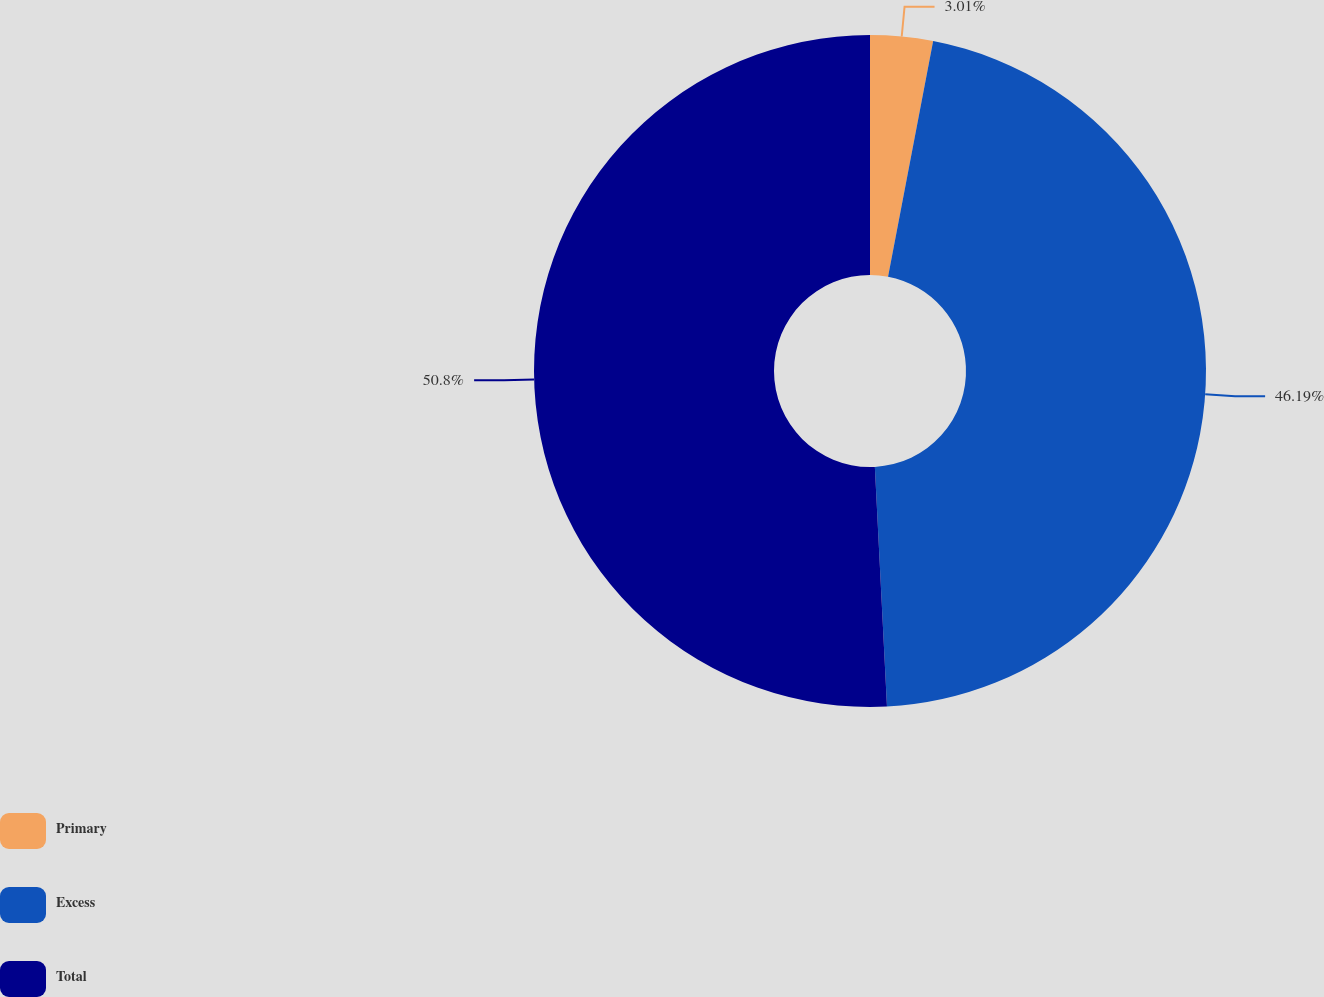<chart> <loc_0><loc_0><loc_500><loc_500><pie_chart><fcel>Primary<fcel>Excess<fcel>Total<nl><fcel>3.01%<fcel>46.19%<fcel>50.81%<nl></chart> 